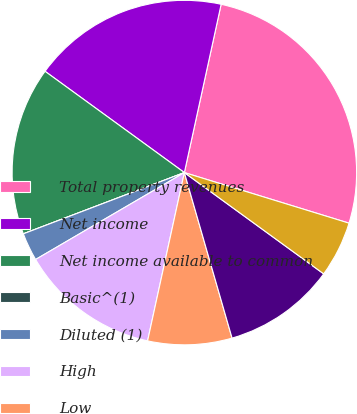<chart> <loc_0><loc_0><loc_500><loc_500><pie_chart><fcel>Total property revenues<fcel>Net income<fcel>Net income available to common<fcel>Basic^(1)<fcel>Diluted (1)<fcel>High<fcel>Low<fcel>Close<fcel>Dividends declared<nl><fcel>26.32%<fcel>18.42%<fcel>15.79%<fcel>0.0%<fcel>2.63%<fcel>13.16%<fcel>7.89%<fcel>10.53%<fcel>5.26%<nl></chart> 